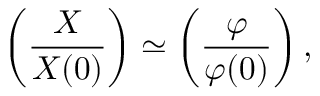<formula> <loc_0><loc_0><loc_500><loc_500>\left ( \frac { X } { X ( 0 ) } \right ) \simeq \left ( \frac { \varphi } { \varphi ( 0 ) } \right ) ,</formula> 